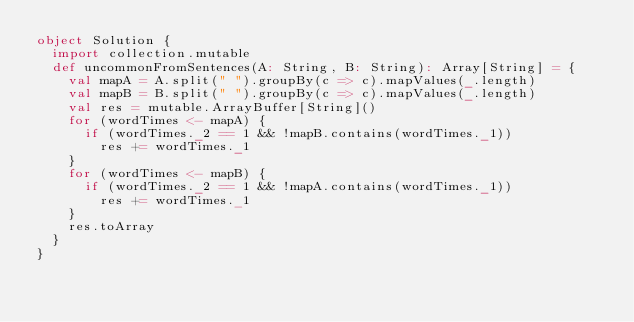Convert code to text. <code><loc_0><loc_0><loc_500><loc_500><_Scala_>object Solution {
  import collection.mutable
  def uncommonFromSentences(A: String, B: String): Array[String] = {
    val mapA = A.split(" ").groupBy(c => c).mapValues(_.length)
    val mapB = B.split(" ").groupBy(c => c).mapValues(_.length)
    val res = mutable.ArrayBuffer[String]()
    for (wordTimes <- mapA) {
      if (wordTimes._2 == 1 && !mapB.contains(wordTimes._1))
        res += wordTimes._1
    }
    for (wordTimes <- mapB) {
      if (wordTimes._2 == 1 && !mapA.contains(wordTimes._1))
        res += wordTimes._1
    }
    res.toArray
  }
}</code> 